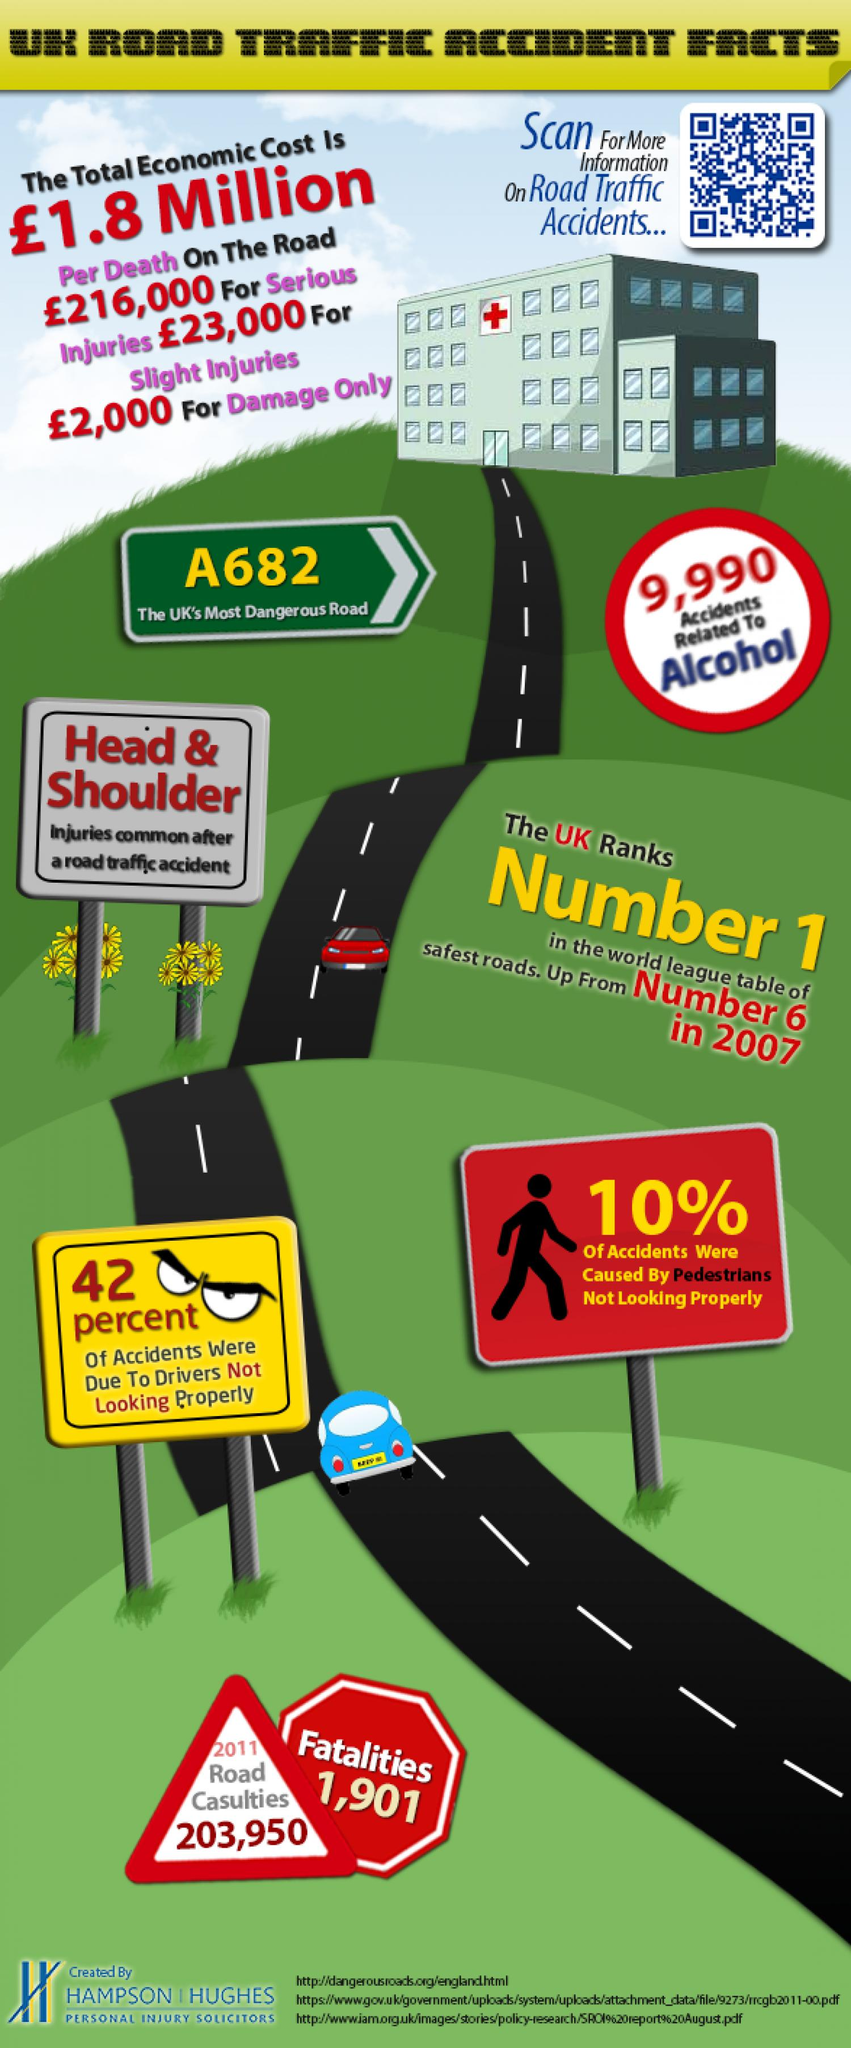Indicate a few pertinent items in this graphic. In 2011, a total of 203,950 casualties were reported as a result of road accidents in the United Kingdom. In the UK, approximately 9,990 accidents are caused by alcohol. In 2011, a total of 1,901 fatalities were reported in road accidents in the United Kingdom. 